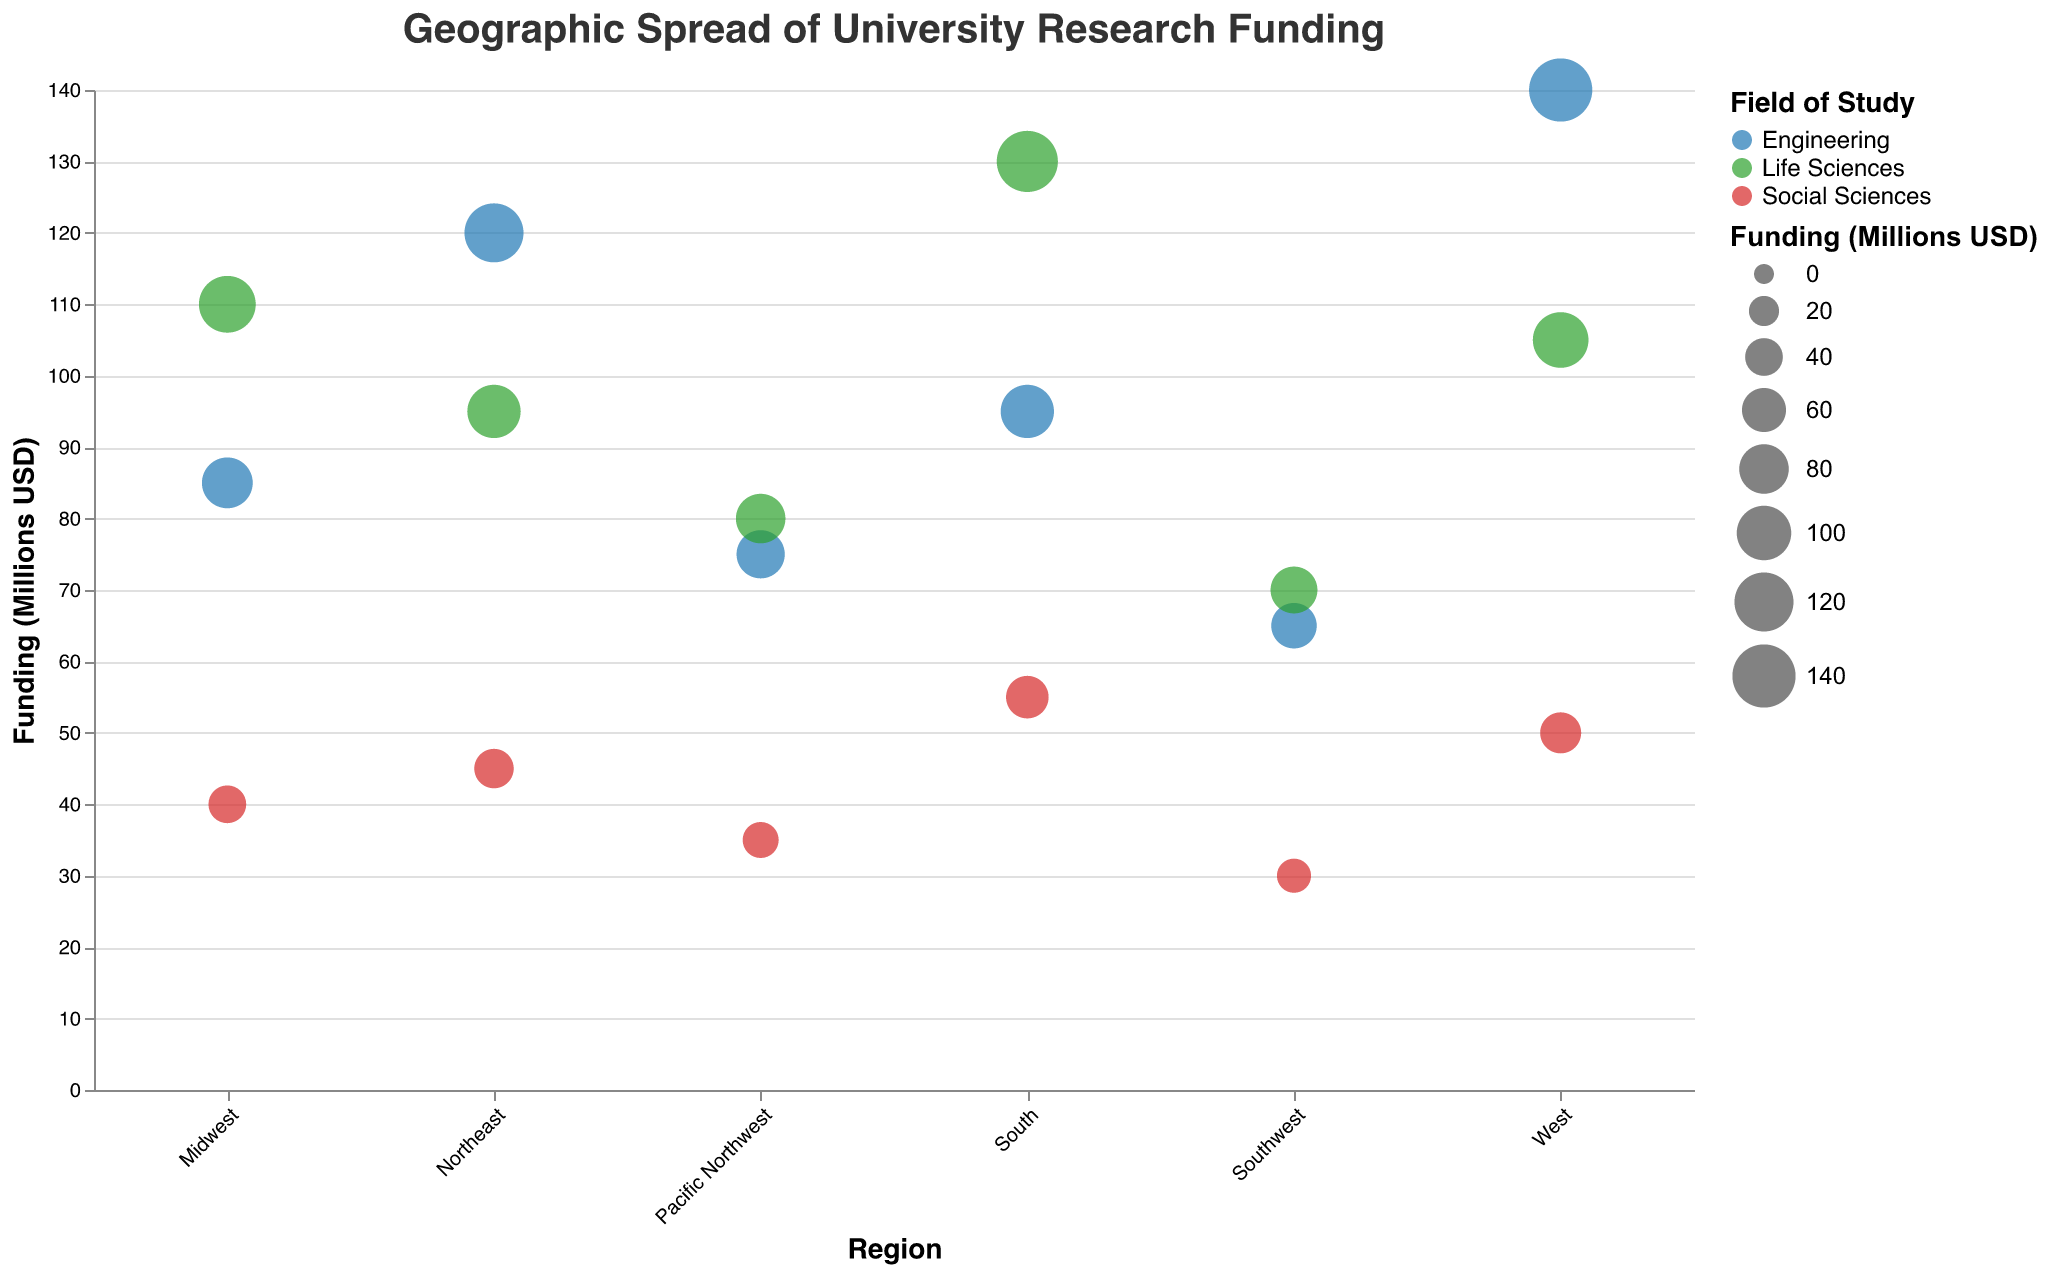What is the total funding for Engineering across all regions? Sum the funding amounts for Engineering in all regions: 120 (Northeast) + 85 (Midwest) + 95 (South) + 140 (West) + 75 (Pacific Northwest) + 65 (Southwest) = 580
Answer: 580 Which region received the highest funding for Life Sciences? Compare the funding for Life Sciences across all regions: Northeast (95), Midwest (110), South (130), West (105), Pacific Northwest (80), and Southwest (70). The highest is the South with 130.
Answer: South What is the average funding for Social Sciences in the Northeast, Midwest, and South? Sum the Social Sciences funding in these regions and divide by the number of regions: (45 + 40 + 55) / 3 = 140 / 3 = 46.67
Answer: 46.67 Which field of study received the least funding in the Southwest? Compare the funding amounts for each field in the Southwest: Engineering (65), Life Sciences (70), Social Sciences (30). The least funding is for Social Sciences with 30.
Answer: Social Sciences How does the funding for Engineering in the Midwest compare to the funding for Life Sciences in the West? Compare the values: Midwest Engineering (85) and West Life Sciences (105). 105 is greater than 85.
Answer: The funding for Life Sciences in the West is higher Which field of study has the most uniform funding distribution across all regions? Assess the spread of funding across regions for each field visually. Engineering and Life Sciences have a wider range, while Social Sciences tends to be more uniform with smaller funding values spread across all regions.
Answer: Social Sciences What is the total research funding for the South? Sum the funding amounts for all fields in the South: Engineering (95) + Life Sciences (130) + Social Sciences (55) = 280
Answer: 280 